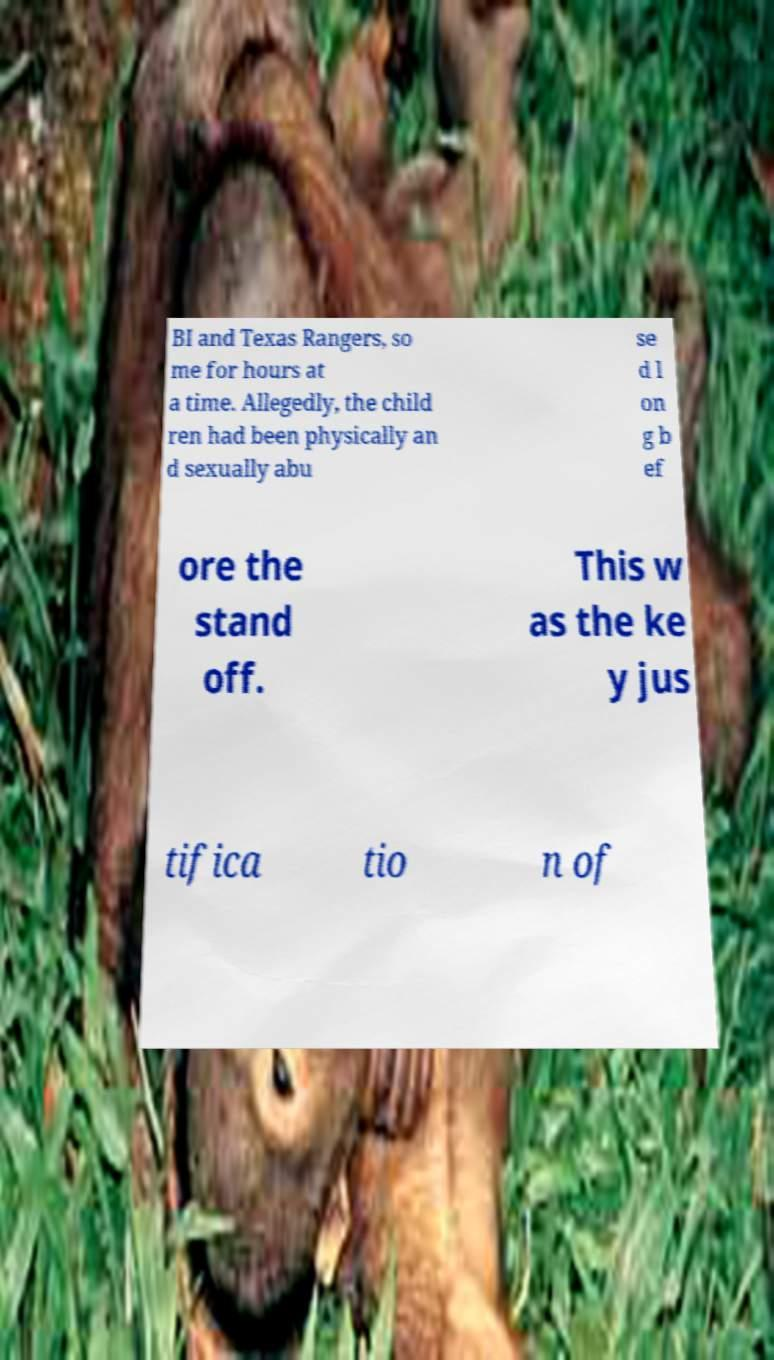I need the written content from this picture converted into text. Can you do that? BI and Texas Rangers, so me for hours at a time. Allegedly, the child ren had been physically an d sexually abu se d l on g b ef ore the stand off. This w as the ke y jus tifica tio n of 